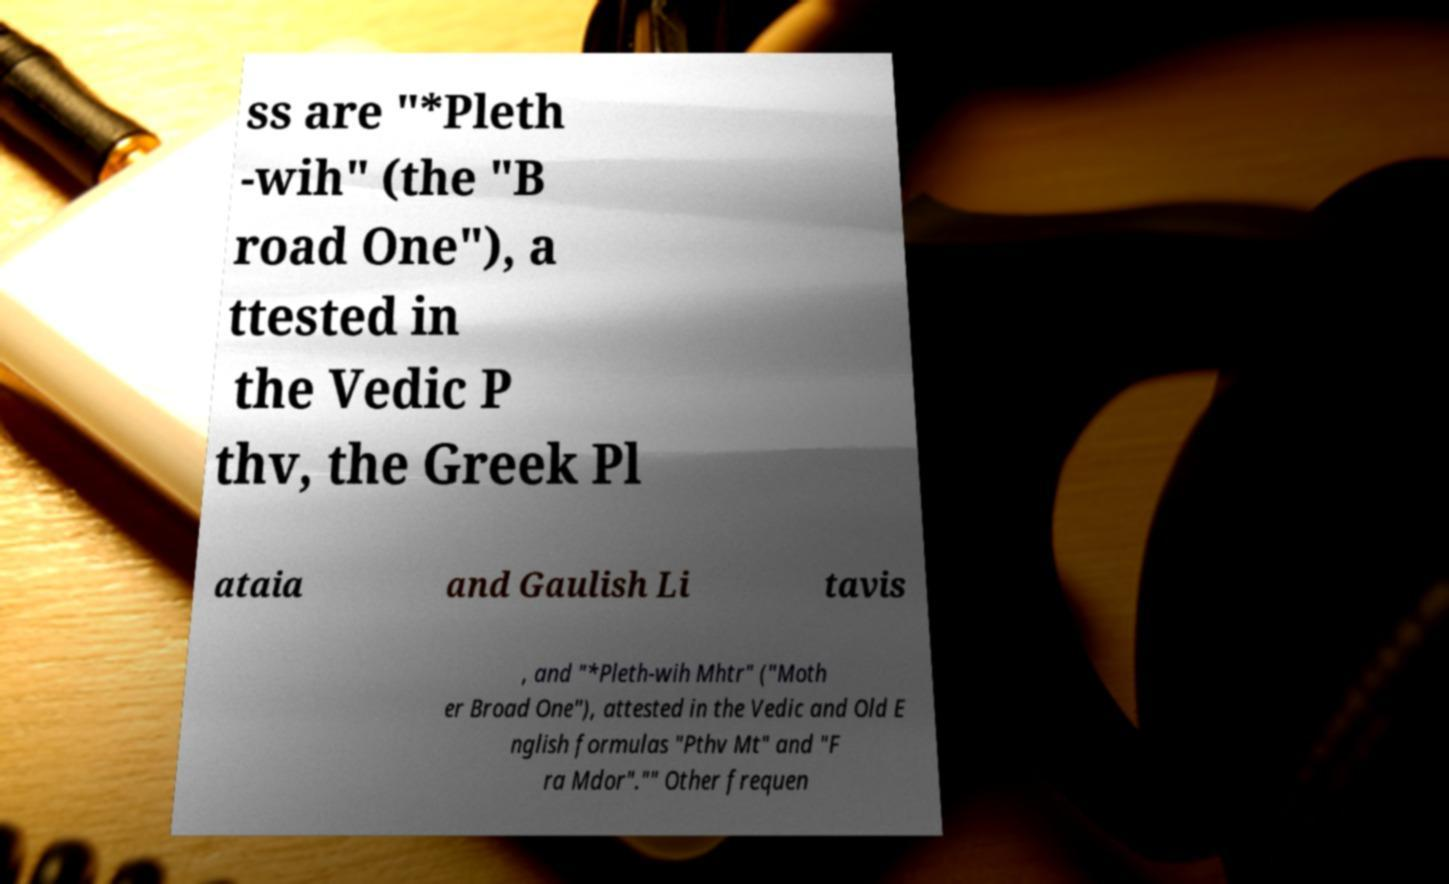Can you read and provide the text displayed in the image?This photo seems to have some interesting text. Can you extract and type it out for me? ss are "*Pleth -wih" (the "B road One"), a ttested in the Vedic P thv, the Greek Pl ataia and Gaulish Li tavis , and "*Pleth-wih Mhtr" ("Moth er Broad One"), attested in the Vedic and Old E nglish formulas "Pthv Mt" and "F ra Mdor"."" Other frequen 